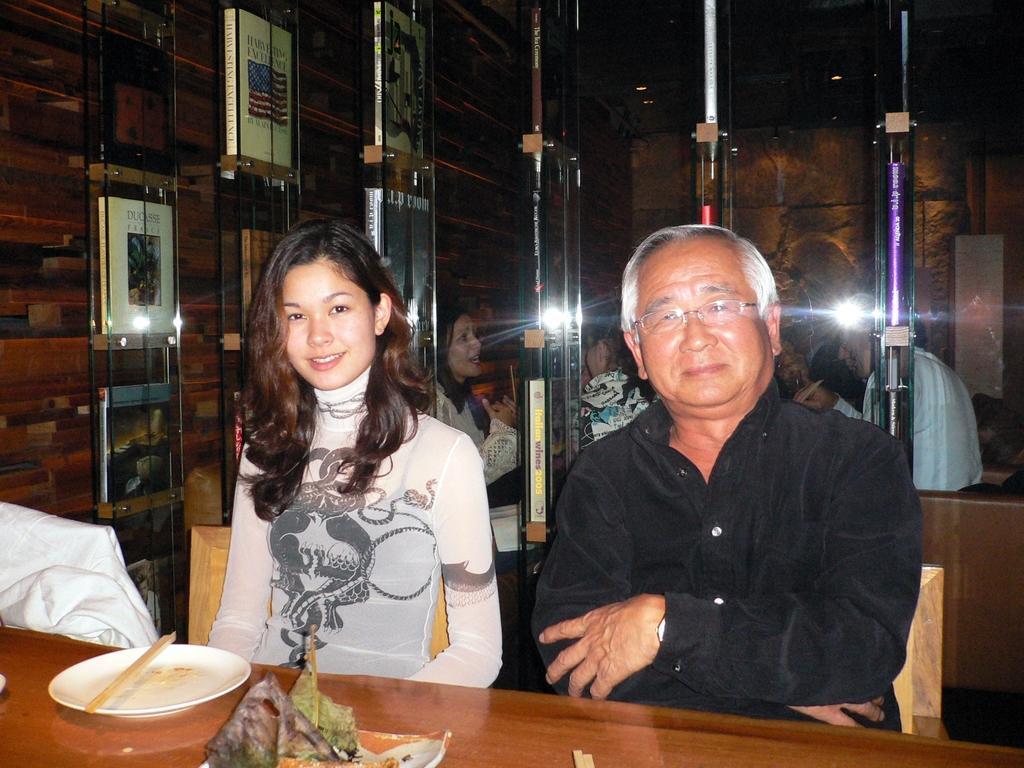In one or two sentences, can you explain what this image depicts? This is the picture taken in a restaurant, there are group of people sitting on chairs in front of these people there is a wooden table on the table there are plates, chopsticks. Beside the people there is a wooden and a glass shelf in the shelf there are some books. 